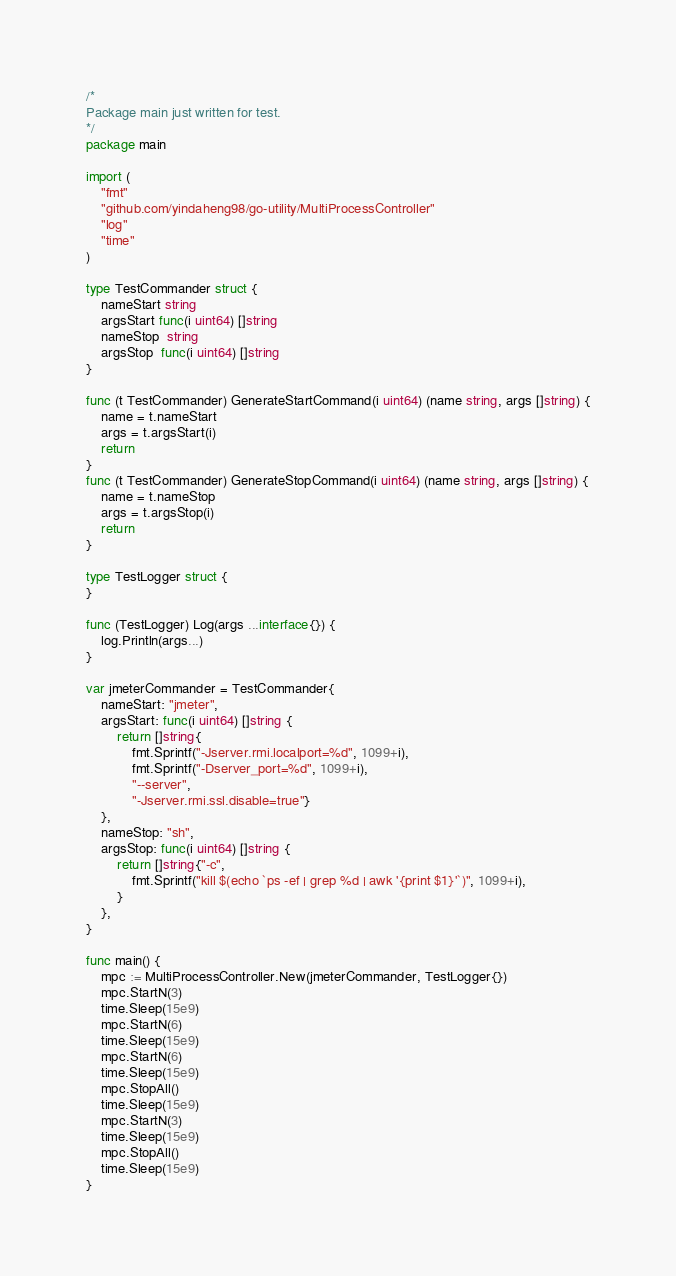Convert code to text. <code><loc_0><loc_0><loc_500><loc_500><_Go_>/*
Package main just written for test.
*/
package main

import (
	"fmt"
	"github.com/yindaheng98/go-utility/MultiProcessController"
	"log"
	"time"
)

type TestCommander struct {
	nameStart string
	argsStart func(i uint64) []string
	nameStop  string
	argsStop  func(i uint64) []string
}

func (t TestCommander) GenerateStartCommand(i uint64) (name string, args []string) {
	name = t.nameStart
	args = t.argsStart(i)
	return
}
func (t TestCommander) GenerateStopCommand(i uint64) (name string, args []string) {
	name = t.nameStop
	args = t.argsStop(i)
	return
}

type TestLogger struct {
}

func (TestLogger) Log(args ...interface{}) {
	log.Println(args...)
}

var jmeterCommander = TestCommander{
	nameStart: "jmeter",
	argsStart: func(i uint64) []string {
		return []string{
			fmt.Sprintf("-Jserver.rmi.localport=%d", 1099+i),
			fmt.Sprintf("-Dserver_port=%d", 1099+i),
			"--server",
			"-Jserver.rmi.ssl.disable=true"}
	},
	nameStop: "sh",
	argsStop: func(i uint64) []string {
		return []string{"-c",
			fmt.Sprintf("kill $(echo `ps -ef | grep %d | awk '{print $1}'`)", 1099+i),
		}
	},
}

func main() {
	mpc := MultiProcessController.New(jmeterCommander, TestLogger{})
	mpc.StartN(3)
	time.Sleep(15e9)
	mpc.StartN(6)
	time.Sleep(15e9)
	mpc.StartN(6)
	time.Sleep(15e9)
	mpc.StopAll()
	time.Sleep(15e9)
	mpc.StartN(3)
	time.Sleep(15e9)
	mpc.StopAll()
	time.Sleep(15e9)
}
</code> 